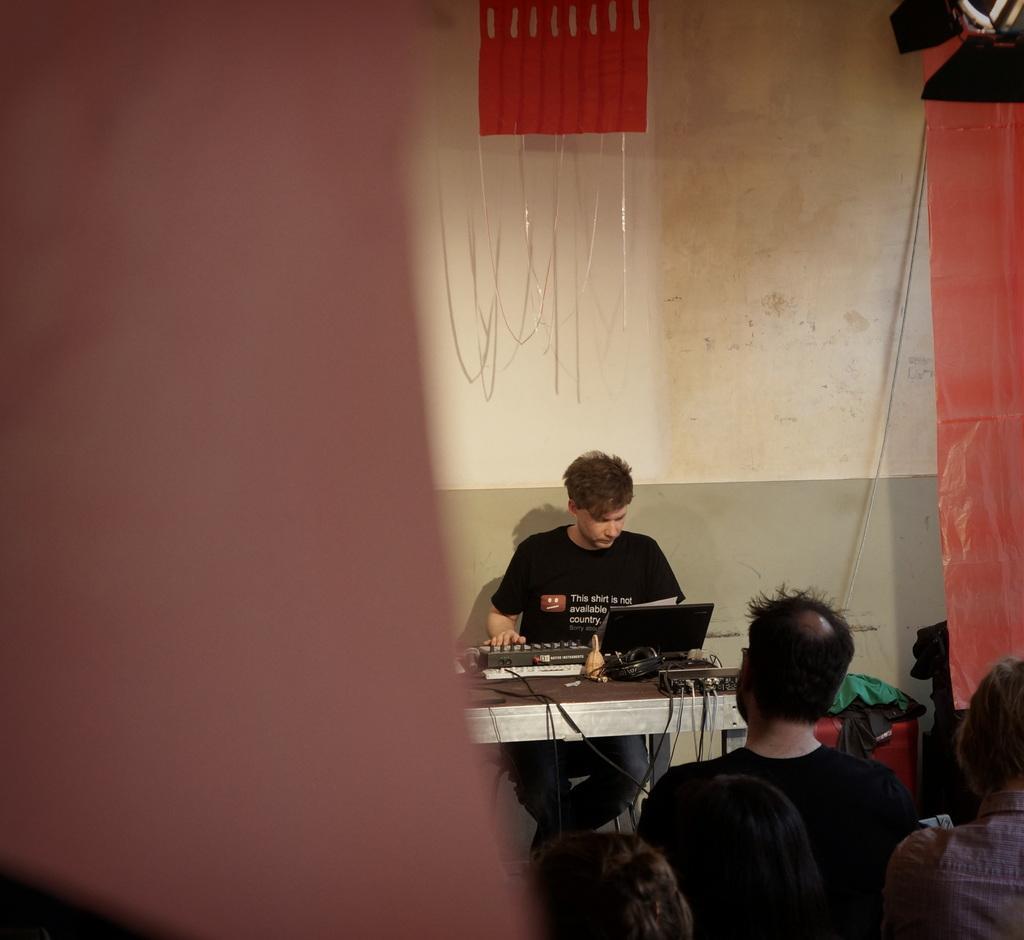In one or two sentences, can you explain what this image depicts? In this picture we can see group of people a person is seated on the chair, and he is operating a machine which is on the table. 